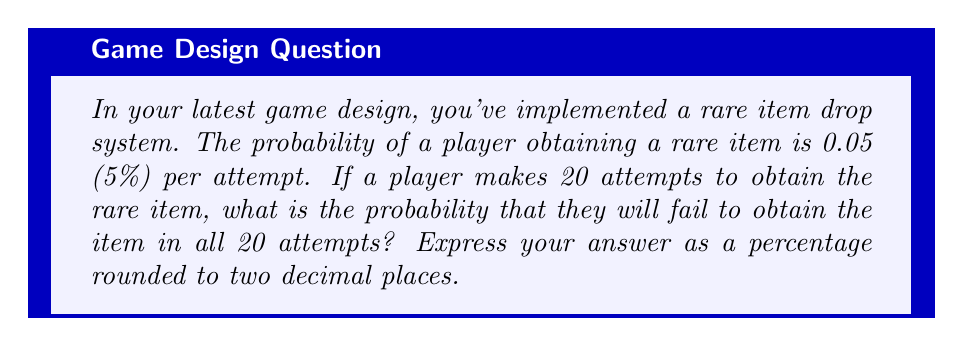What is the answer to this math problem? Let's approach this step-by-step:

1) First, we need to calculate the probability of not getting the rare item in a single attempt. If the probability of getting the item is 0.05, then the probability of not getting it is:

   $1 - 0.05 = 0.95$ or 95%

2) Now, we need to consider all 20 attempts. The probability of failing all 20 times is the probability of failing once, raised to the power of 20 (because the events are independent and we want all of them to occur).

3) We can express this using exponents:

   $$(0.95)^{20}$$

4) To calculate this:

   $$(0.95)^{20} \approx 0.3585$$

5) To convert to a percentage, we multiply by 100:

   $$0.3585 \times 100 \approx 35.85\%$$

6) Rounding to two decimal places gives us 35.85%

This means there's about a 35.85% chance that a player will fail to get the rare item after 20 attempts.
Answer: 35.85% 